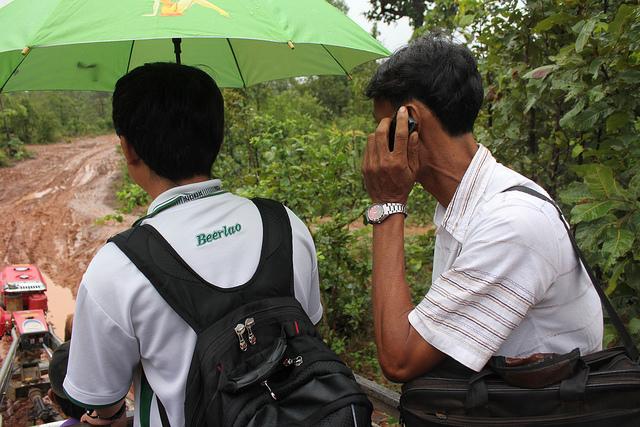What color are the bags?
Short answer required. Black. What color is the umbrella?
Be succinct. Green. Is the man talking on the phone?
Give a very brief answer. Yes. 